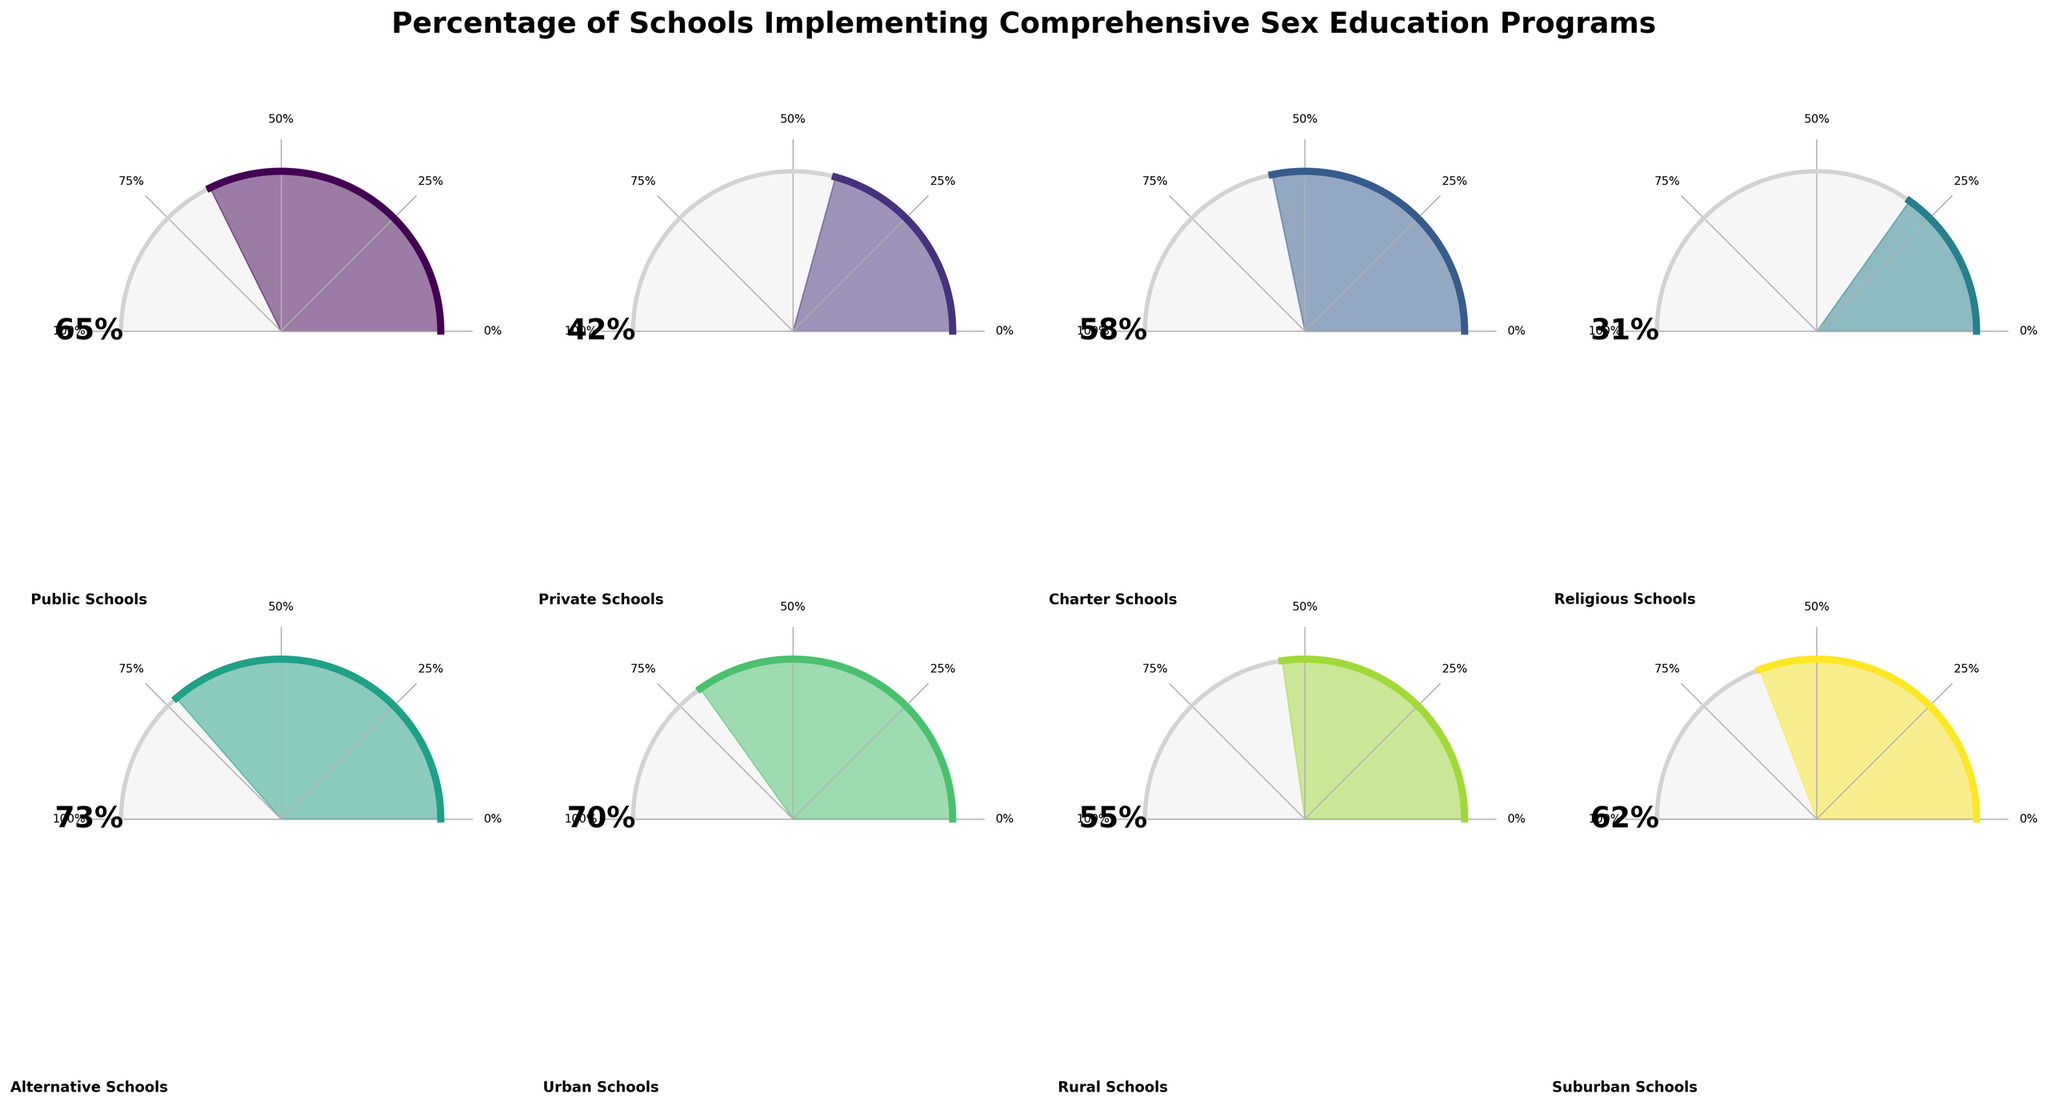Which type of school has the highest percentage of implementing comprehensive sex education programs? Look for the gauge with the highest percentage. The Alternative Schools gauge reads 73%, which is higher than all other categories.
Answer: Alternative Schools Which type of school has the lowest percentage of implementing comprehensive sex education programs? Look for the gauge with the lowest percentage. The Religious Schools gauge reads 31%, which is lower than all other categories.
Answer: Religious Schools What is the percentage of Public Schools implementing comprehensive sex education programs? Find the gauge labeled "Public Schools". The percentage shown is 65%.
Answer: 65% Which types of schools have an implementation percentage of 55% or higher? Check each gauge and note the percentages. Public Schools (65%), Charter Schools (58%), Alternative Schools (73%), Urban Schools (70%), Rural Schools (55%), and Suburban Schools (62%) all meet this criterion.
Answer: Public Schools, Charter Schools, Alternative Schools, Urban Schools, Rural Schools, Suburban Schools How does the implementation percentage of Private Schools compare to that of Charter Schools? Check each gauge for Private Schools and Charter Schools. Private Schools have 42% and Charter Schools have 58%. Charter Schools implement at a higher rate.
Answer: Charter Schools have a higher percentage What is the average percentage of implementing comprehensive sex education programs across all types of schools? Sum the percentages from all eight gauges and divide by the number of categories. (65+42+58+31+73+70+55+62)/8 = 57
Answer: 57 Which school type is closest to the implementation percentage of Urban Schools? Urban Schools have 70%. The closest percentage is that of Suburban Schools at 62%.
Answer: Suburban Schools What is the median implementation percentage of comprehensive sex education programs across the listed school types? Arrange percentages in ascending order: 31, 42, 55, 58, 62, 65, 70, 73. The median is the average of the 4th and 5th values: (58 + 62)/2 = 60
Answer: 60 Are there more school types with implementation percentages above or below 50%? Count the gauges above 50%: Public Schools (65), Charter Schools (58), Alternative Schools (73), Urban Schools (70), Rural Schools (55), Suburban Schools (62). Count gauges below: Private Schools (42), Religious Schools (31). More above (6) than below (2).
Answer: More above 50% What is the difference in implementation percentage between Religious Schools and Public Schools? Subtract the percentage of Religious Schools (31) from Public Schools (65). 65 - 31 = 34
Answer: 34 